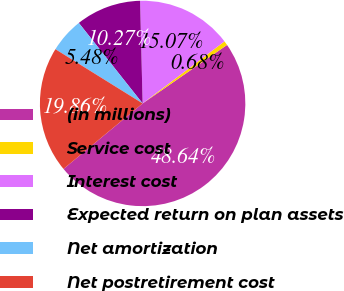Convert chart. <chart><loc_0><loc_0><loc_500><loc_500><pie_chart><fcel>(in millions)<fcel>Service cost<fcel>Interest cost<fcel>Expected return on plan assets<fcel>Net amortization<fcel>Net postretirement cost<nl><fcel>48.64%<fcel>0.68%<fcel>15.07%<fcel>10.27%<fcel>5.48%<fcel>19.86%<nl></chart> 